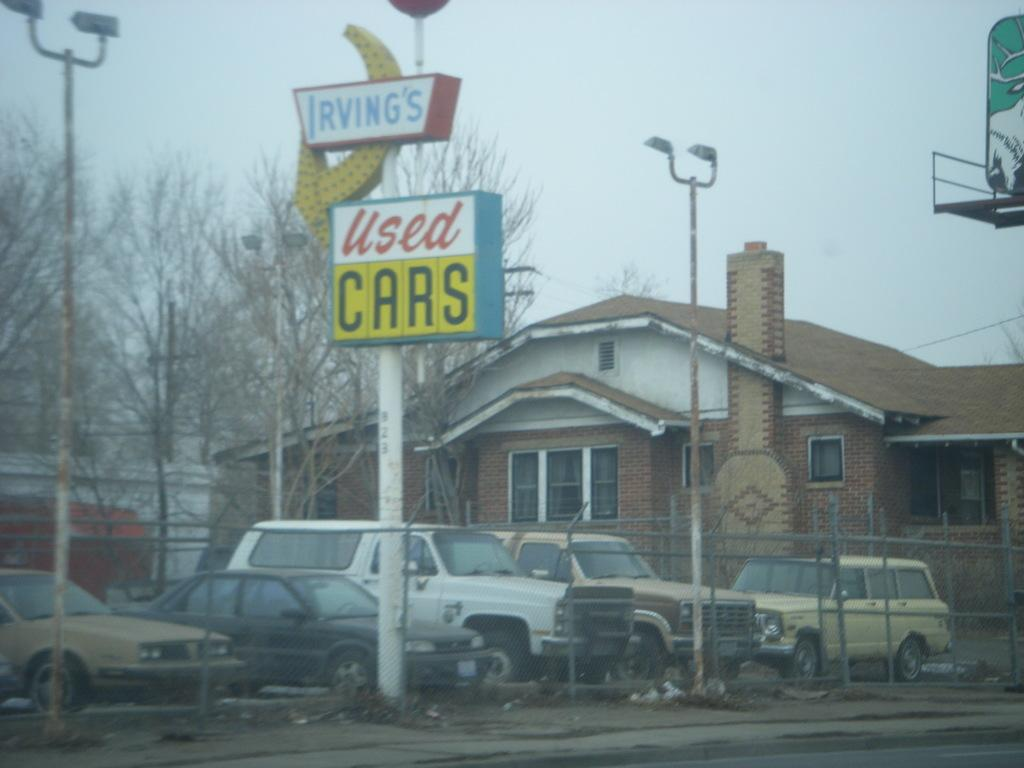What type of vehicles can be seen in the image? There are cars in the image. What structure is present in the image? There is a building in the image. What type of vegetation is visible in the image? There are trees in the image. What object is present that might be used for support or signage? There is a pole in the image. What can be read or seen on the board in the image? There is a board with text in the image. Where is the tent located in the image? There is no tent present in the image. What type of food is being served for dinner in the image? There is no dinner or food being served in the image. 